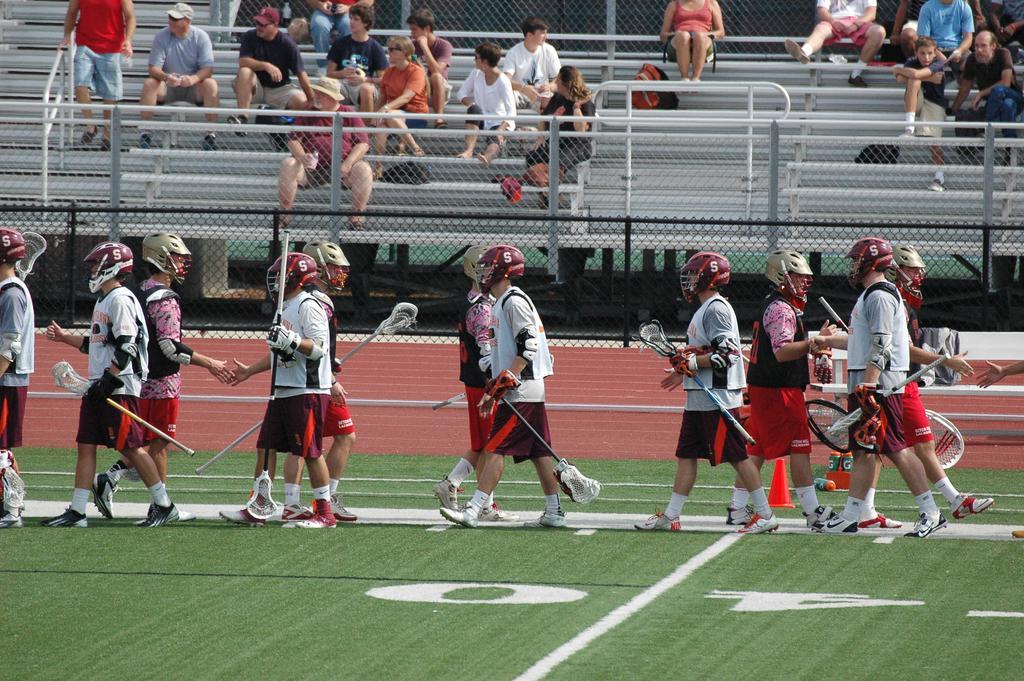How would you summarize this image in a sentence or two? In this image few persons are walking on the grass land. They are wearing helmets and they are holding sticks in their hands. Behind them there is a fence. Few persons are sitting on the stairs. Left top of image there is a person wearing a red top is holding the fence. 